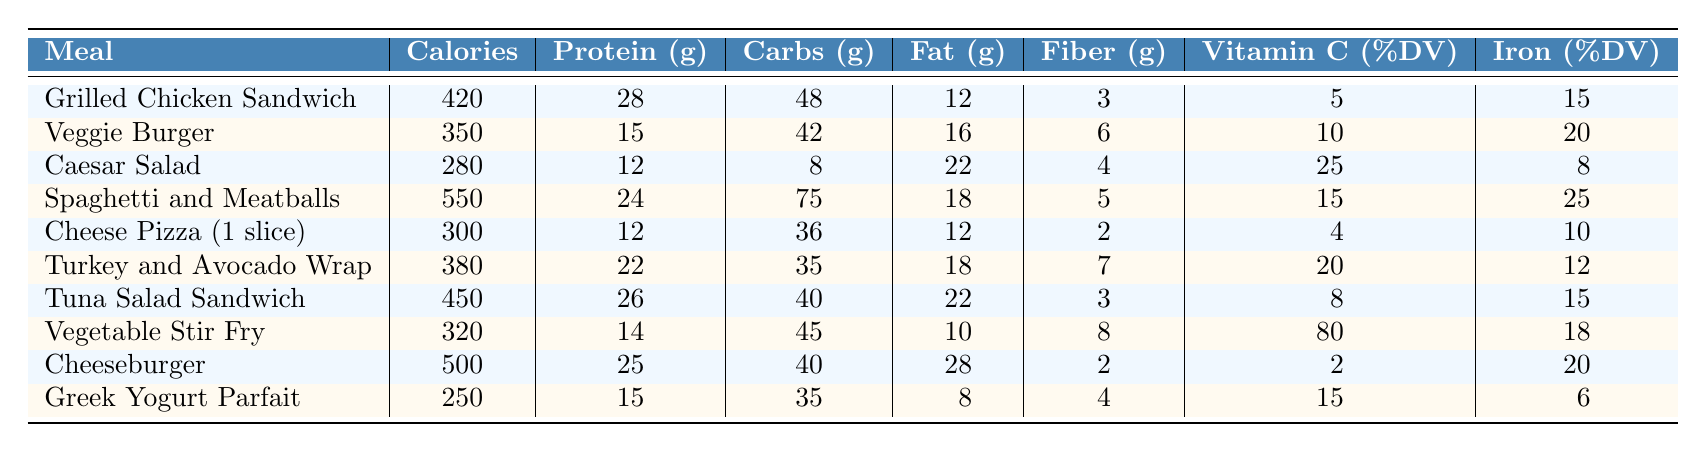What is the highest calorie meal listed? The meal with the highest calorie count is "Spaghetti and Meatballs," which has 550 calories. I obtained this by comparing the calorie values of all meals in the table.
Answer: Spaghetti and Meatballs Which meal has the most protein? "Tuna Salad Sandwich" has the highest protein content with 26 grams. I found this by looking at the protein column and identifying the maximum value.
Answer: Tuna Salad Sandwich What is the average amount of fat in these meals? To find the average fat content, I sum the fat values (12 + 16 + 22 + 18 + 12 + 18 + 22 + 10 + 28 + 8 =  172) and divide by the number of meals (10), which gives an average of 17.2 grams.
Answer: 17.2 grams Is the fiber content of the Veggie Burger higher than that of the Caesar Salad? The fiber content of the Veggie Burger is 6 grams, and for the Caesar Salad it is 4 grams. Since 6 grams is greater than 4 grams, the statement is true.
Answer: Yes How many meals contain at least 20% Vitamin C? "Spaghetti and Meatballs," "Turkey and Avocado Wrap," and "Vegetable Stir Fry" have Vitamin C values of 15%, 20%, and 80%, respectively. This gives a total of three meals.
Answer: 3 Which meal has both the highest fat and calorie counts? "Cheeseburger" has the highest fat content (28 grams) and is also one of the highest calorie meals (500 calories). I checked the calorie and fat columns to confirm this.
Answer: Cheeseburger If you were to choose the meal with the least calories and the most fiber, which one would it be? The meal with the lowest calories is the "Greek Yogurt Parfait" at 250 calories and it has 4 grams of fiber. Comparing this with the other meals, it has the least caloric value with reasonable fiber content.
Answer: Greek Yogurt Parfait What is the difference in iron content between the Cheeseburger and Cheese Pizza? The Cheeseburger has 20% iron and the Cheese Pizza has 10% iron. The difference is 20% - 10% = 10%. So, the Cheeseburger contains 10% more iron than the Cheese Pizza.
Answer: 10% Which meal has the least amount of carbohydrates, and what is that value? The meal with the least amount of carbohydrates is "Caesar Salad," which has 8 grams of carbs. I identified this by scanning the carbohydrate column for the lowest number.
Answer: 8 grams If you have a goal of consuming at least 500 calories, how many meals meet this requirement? The meals that have 500 or more calories are "Spaghetti and Meatballs" (550) and "Cheeseburger" (500). This totals two meals that meet the calorie requirement.
Answer: 2 